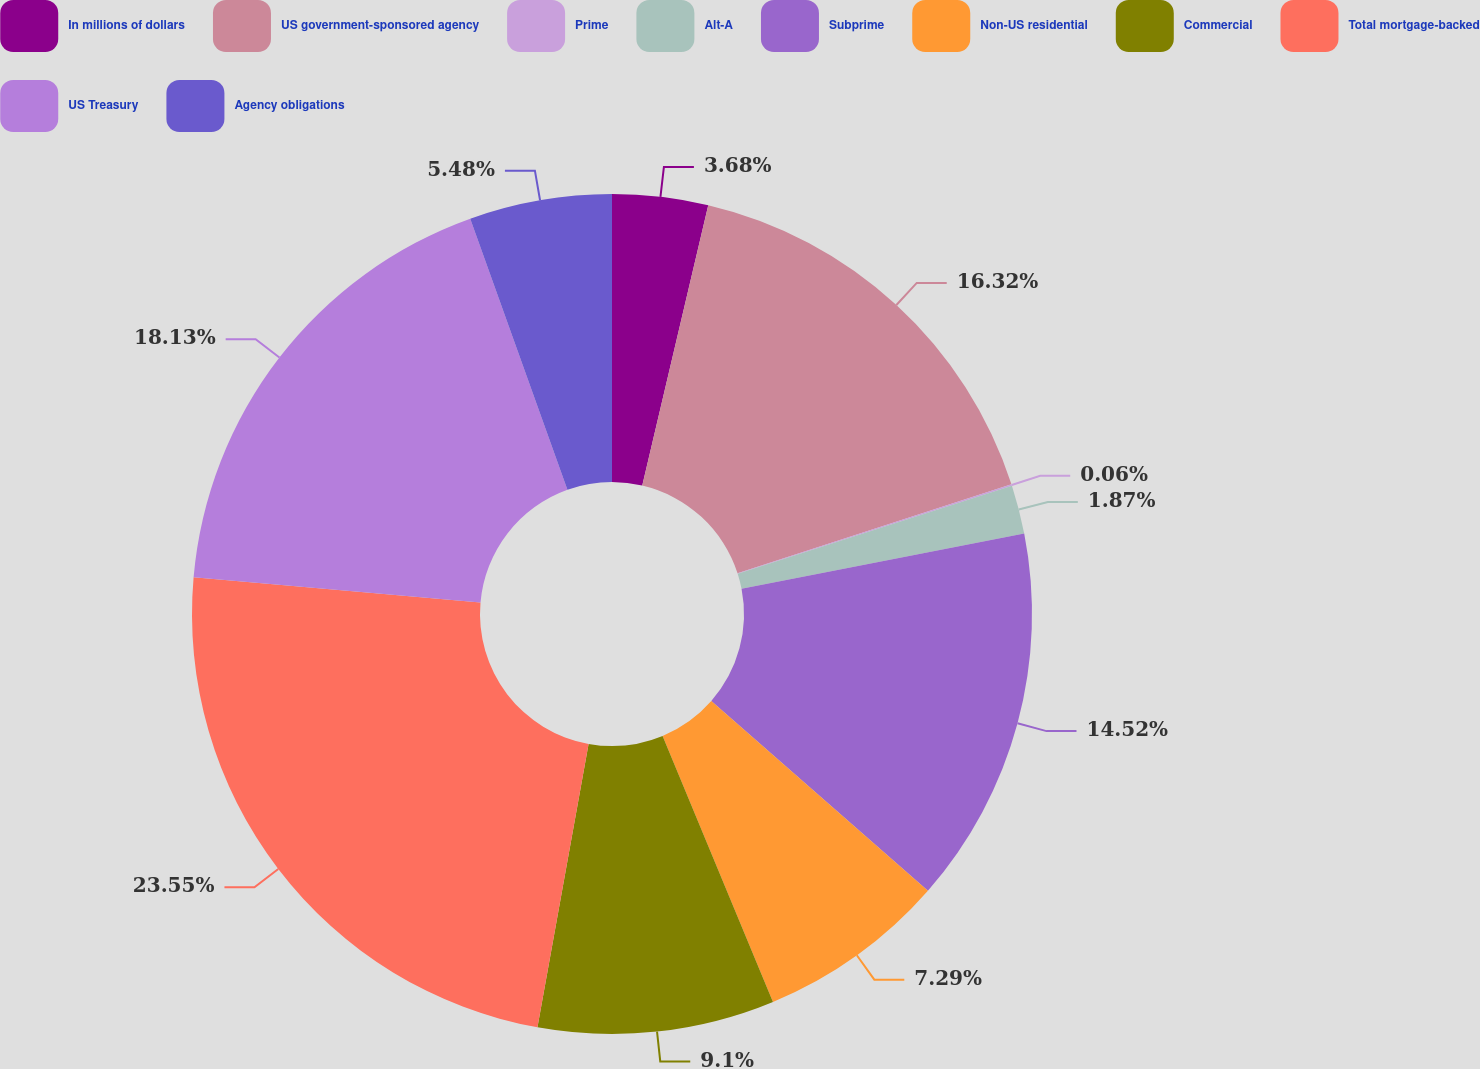<chart> <loc_0><loc_0><loc_500><loc_500><pie_chart><fcel>In millions of dollars<fcel>US government-sponsored agency<fcel>Prime<fcel>Alt-A<fcel>Subprime<fcel>Non-US residential<fcel>Commercial<fcel>Total mortgage-backed<fcel>US Treasury<fcel>Agency obligations<nl><fcel>3.68%<fcel>16.32%<fcel>0.06%<fcel>1.87%<fcel>14.52%<fcel>7.29%<fcel>9.1%<fcel>23.55%<fcel>18.13%<fcel>5.48%<nl></chart> 